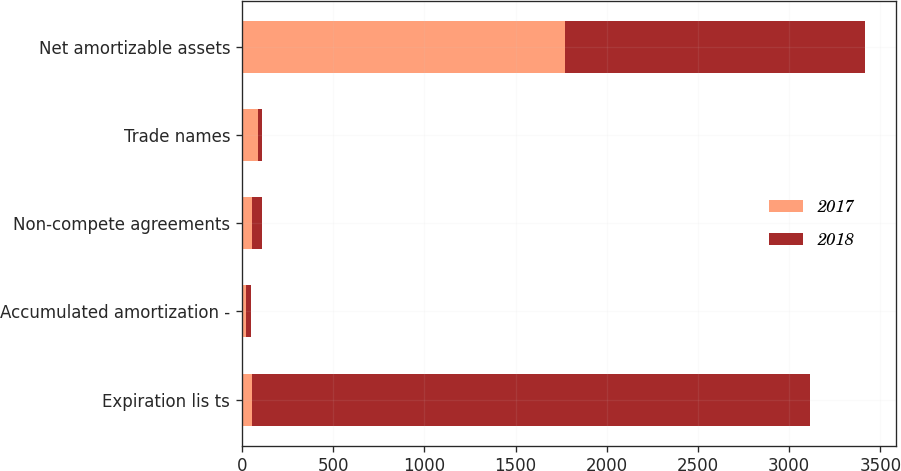Convert chart to OTSL. <chart><loc_0><loc_0><loc_500><loc_500><stacked_bar_chart><ecel><fcel>Expiration lis ts<fcel>Accumulated amortization -<fcel>Non-compete agreements<fcel>Trade names<fcel>Net amortizable assets<nl><fcel>2017<fcel>58<fcel>25.1<fcel>58<fcel>86<fcel>1773<nl><fcel>2018<fcel>3055.9<fcel>22.5<fcel>53.5<fcel>25.9<fcel>1644.6<nl></chart> 